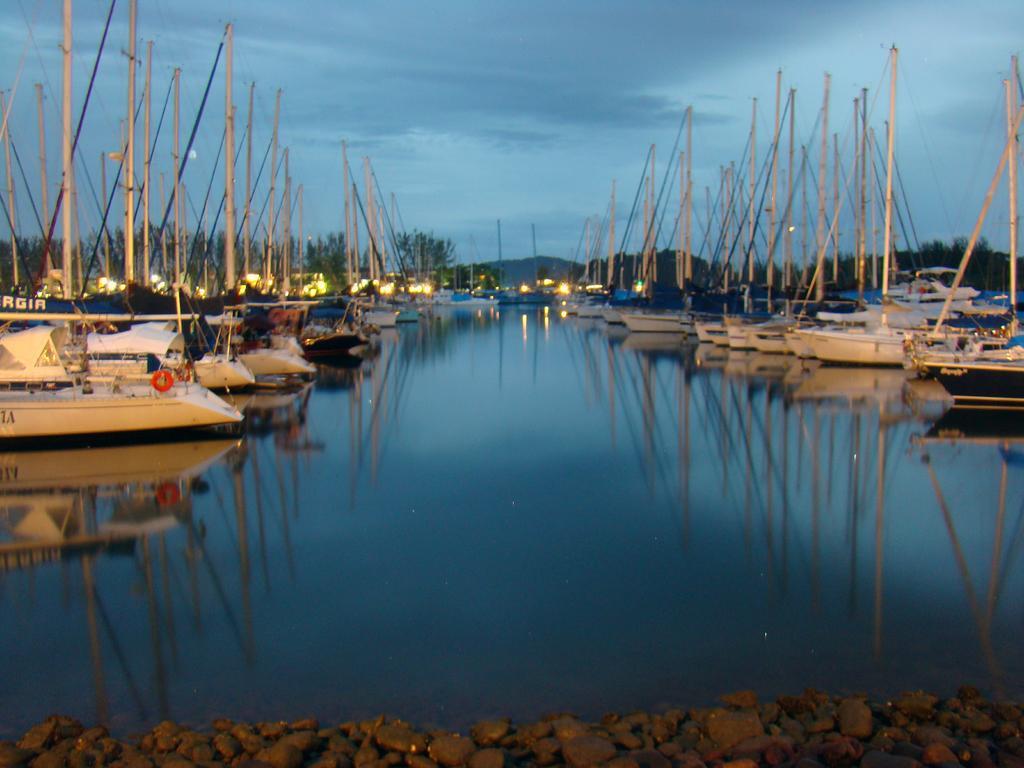Could you give a brief overview of what you see in this image? In the picture there are a lot of ships kept in an order on the river,in the background there are plenty of light sand behind the lights there are some trees. 